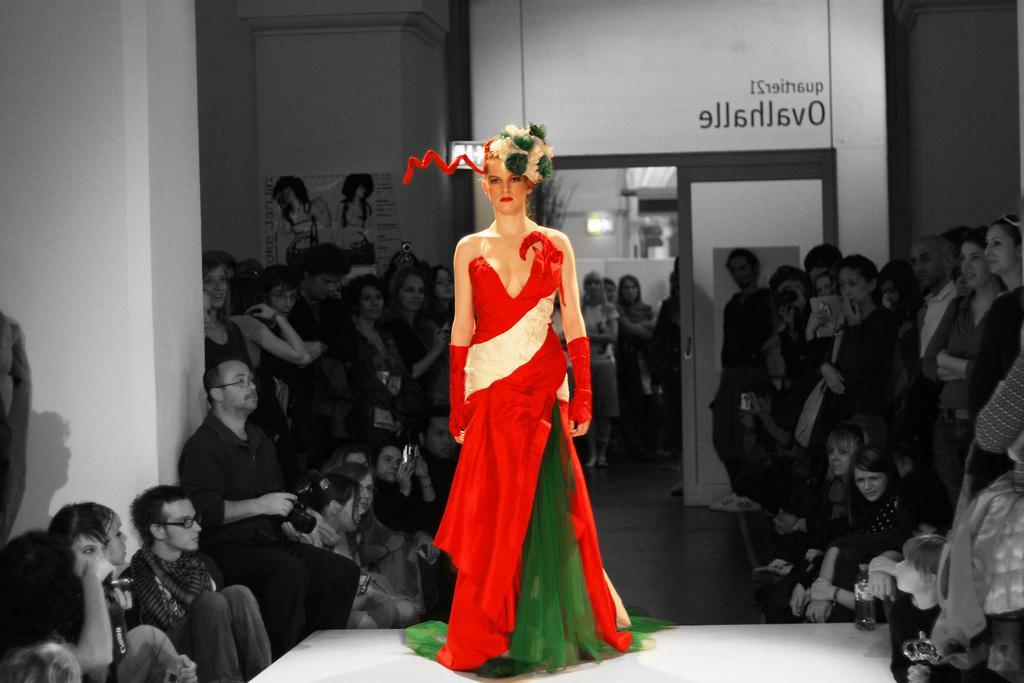Describe this image in one or two sentences. In this image I can see a woman standing on a ramp wearing a specially designed dress. I can see people watching her on both sides of the ramp. I can see some other people far behind her. I can see a door and some text above the door. There is a poster on the wall on the left hand side with some text. The background is black and white except the woman standing on the ramp. 